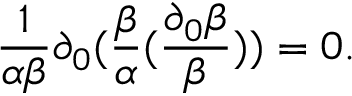Convert formula to latex. <formula><loc_0><loc_0><loc_500><loc_500>\frac { 1 } { \alpha \beta } \partial _ { 0 } ( \frac { \beta } { \alpha } ( \frac { \partial _ { 0 } \beta } { \beta } ) ) = 0 .</formula> 